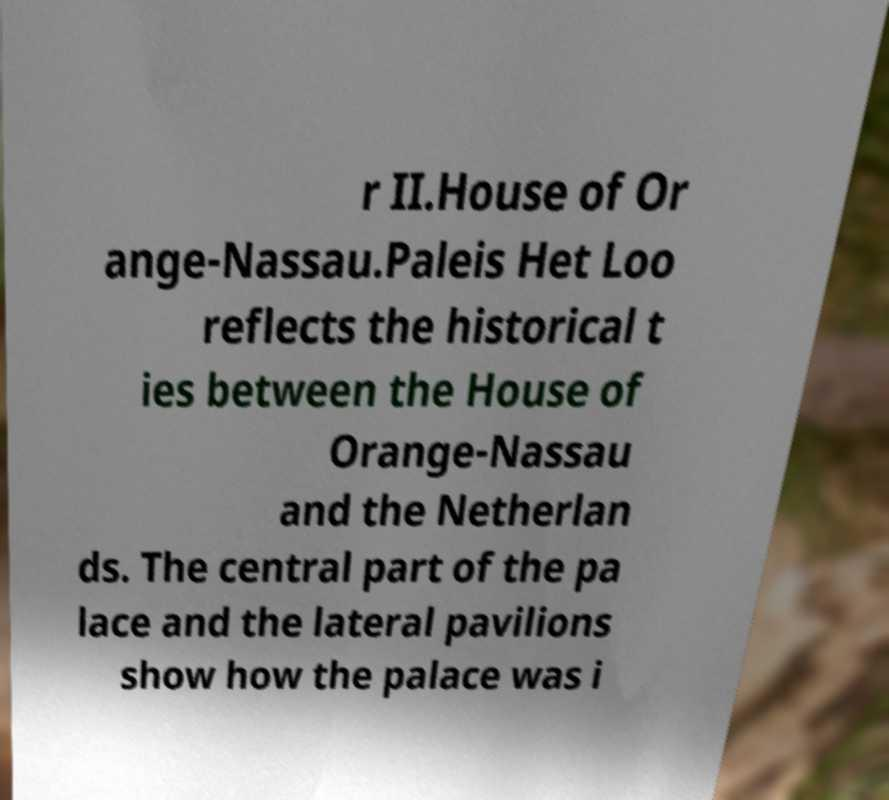Can you accurately transcribe the text from the provided image for me? r II.House of Or ange-Nassau.Paleis Het Loo reflects the historical t ies between the House of Orange-Nassau and the Netherlan ds. The central part of the pa lace and the lateral pavilions show how the palace was i 